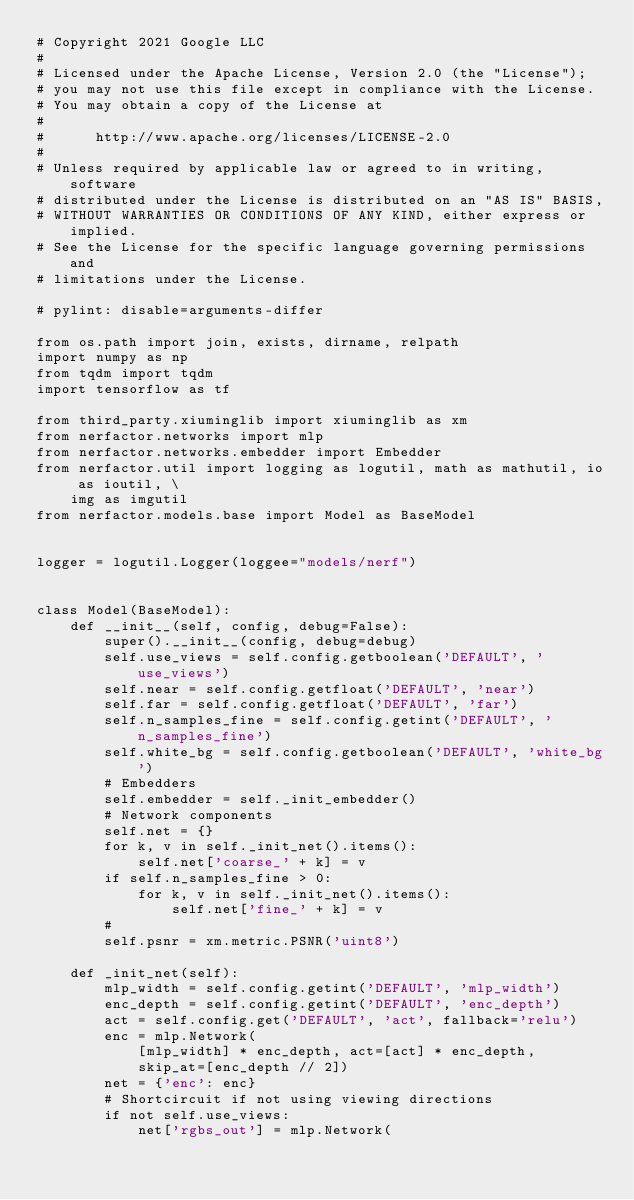<code> <loc_0><loc_0><loc_500><loc_500><_Python_># Copyright 2021 Google LLC
#
# Licensed under the Apache License, Version 2.0 (the "License");
# you may not use this file except in compliance with the License.
# You may obtain a copy of the License at
#
#      http://www.apache.org/licenses/LICENSE-2.0
#
# Unless required by applicable law or agreed to in writing, software
# distributed under the License is distributed on an "AS IS" BASIS,
# WITHOUT WARRANTIES OR CONDITIONS OF ANY KIND, either express or implied.
# See the License for the specific language governing permissions and
# limitations under the License.

# pylint: disable=arguments-differ

from os.path import join, exists, dirname, relpath
import numpy as np
from tqdm import tqdm
import tensorflow as tf

from third_party.xiuminglib import xiuminglib as xm
from nerfactor.networks import mlp
from nerfactor.networks.embedder import Embedder
from nerfactor.util import logging as logutil, math as mathutil, io as ioutil, \
    img as imgutil
from nerfactor.models.base import Model as BaseModel


logger = logutil.Logger(loggee="models/nerf")


class Model(BaseModel):
    def __init__(self, config, debug=False):
        super().__init__(config, debug=debug)
        self.use_views = self.config.getboolean('DEFAULT', 'use_views')
        self.near = self.config.getfloat('DEFAULT', 'near')
        self.far = self.config.getfloat('DEFAULT', 'far')
        self.n_samples_fine = self.config.getint('DEFAULT', 'n_samples_fine')
        self.white_bg = self.config.getboolean('DEFAULT', 'white_bg')
        # Embedders
        self.embedder = self._init_embedder()
        # Network components
        self.net = {}
        for k, v in self._init_net().items():
            self.net['coarse_' + k] = v
        if self.n_samples_fine > 0:
            for k, v in self._init_net().items():
                self.net['fine_' + k] = v
        #
        self.psnr = xm.metric.PSNR('uint8')

    def _init_net(self):
        mlp_width = self.config.getint('DEFAULT', 'mlp_width')
        enc_depth = self.config.getint('DEFAULT', 'enc_depth')
        act = self.config.get('DEFAULT', 'act', fallback='relu')
        enc = mlp.Network(
            [mlp_width] * enc_depth, act=[act] * enc_depth,
            skip_at=[enc_depth // 2])
        net = {'enc': enc}
        # Shortcircuit if not using viewing directions
        if not self.use_views:
            net['rgbs_out'] = mlp.Network(</code> 